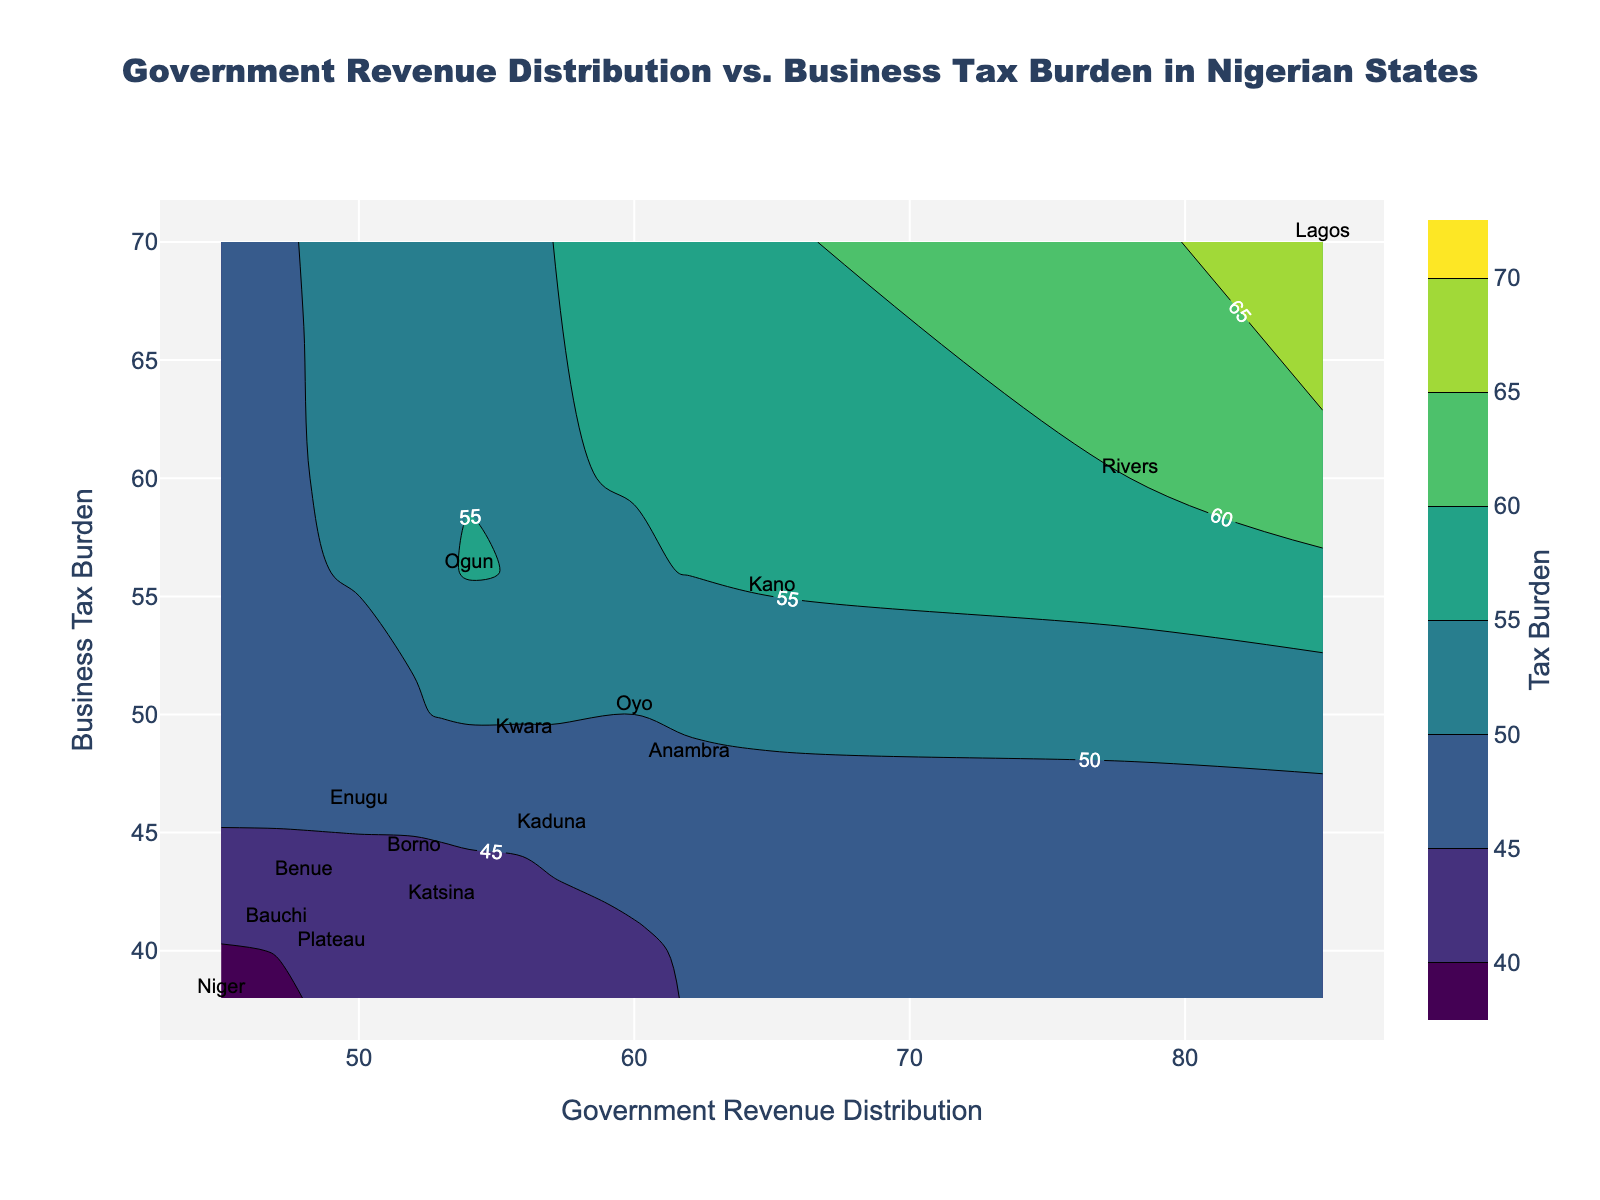What is the title of the figure? The title is usually found at the top of the plot. It provides a brief description of what the figure represents.
Answer: Government Revenue Distribution vs. Business Tax Burden in Nigerian States Which state has the highest government revenue distribution? The state with the highest government revenue distribution can be identified by looking at the point with the highest value on the x-axis and the corresponding state label.
Answer: Lagos What is the government revenue distribution and business tax burden for Rivers state? To find these values, locate Rivers state on the scatter plot and note its position along the x-axis for government revenue distribution and the y-axis for business tax burden.
Answer: Government Revenue Distribution: 78, Business Tax Burden: 60 How many states have a business tax burden of over 50? Count the number of points on the scatter plot where the y-axis value (Business Tax Burden) is greater than 50.
Answer: 6 states Which state has the least business tax burden and what is its value? Find the point with the lowest value on the y-axis and note the corresponding state label and its position on the y-axis.
Answer: Niger, 38 Compare the business tax burden between Lagos and Ogun. Locate Lagos and Ogun on the scatter plot and compare their positions along the y-axis. Lagos has a higher value.
Answer: Lagos: 70, Ogun: 56 What is the average government revenue distribution for the states named in the plot? Sum the government revenue distribution values of all states and divide by the number of states. (85 + 65 + 78 + 60 + 57 + 62 + 54 + 50 + 53 + 45 + 52 + 56 + 47 + 48 + 49) / 15 = 57.8
Answer: 57.8 Which state lies at the intersection of the contour lines representing a 50 business tax burden? Find the contour line labeled '50' and locate the state at the point where this line intersects with the curve.
Answer: Enugu How does the government revenue distribution for Katsina compare to Kaduna? Compare their positions along the x-axis. Kaduna has a slightly lower value.
Answer: Katsina: 53, Kaduna: 57 